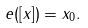Convert formula to latex. <formula><loc_0><loc_0><loc_500><loc_500>e ( [ x ] ) = x _ { 0 } .</formula> 